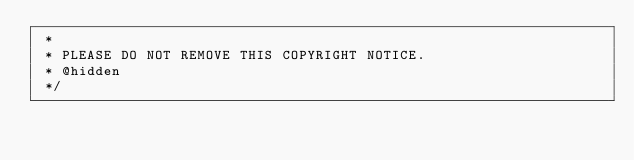Convert code to text. <code><loc_0><loc_0><loc_500><loc_500><_JavaScript_> *
 * PLEASE DO NOT REMOVE THIS COPYRIGHT NOTICE.
 * @hidden
 */</code> 